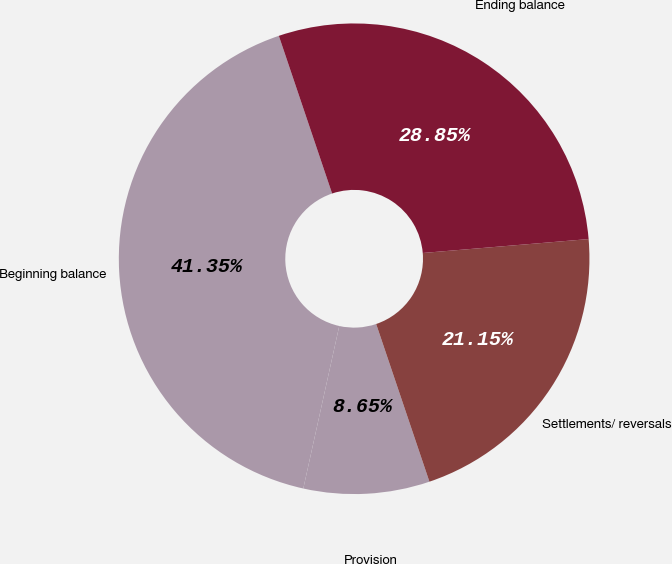<chart> <loc_0><loc_0><loc_500><loc_500><pie_chart><fcel>Beginning balance<fcel>Provision<fcel>Settlements/ reversals<fcel>Ending balance<nl><fcel>41.35%<fcel>8.65%<fcel>21.15%<fcel>28.85%<nl></chart> 